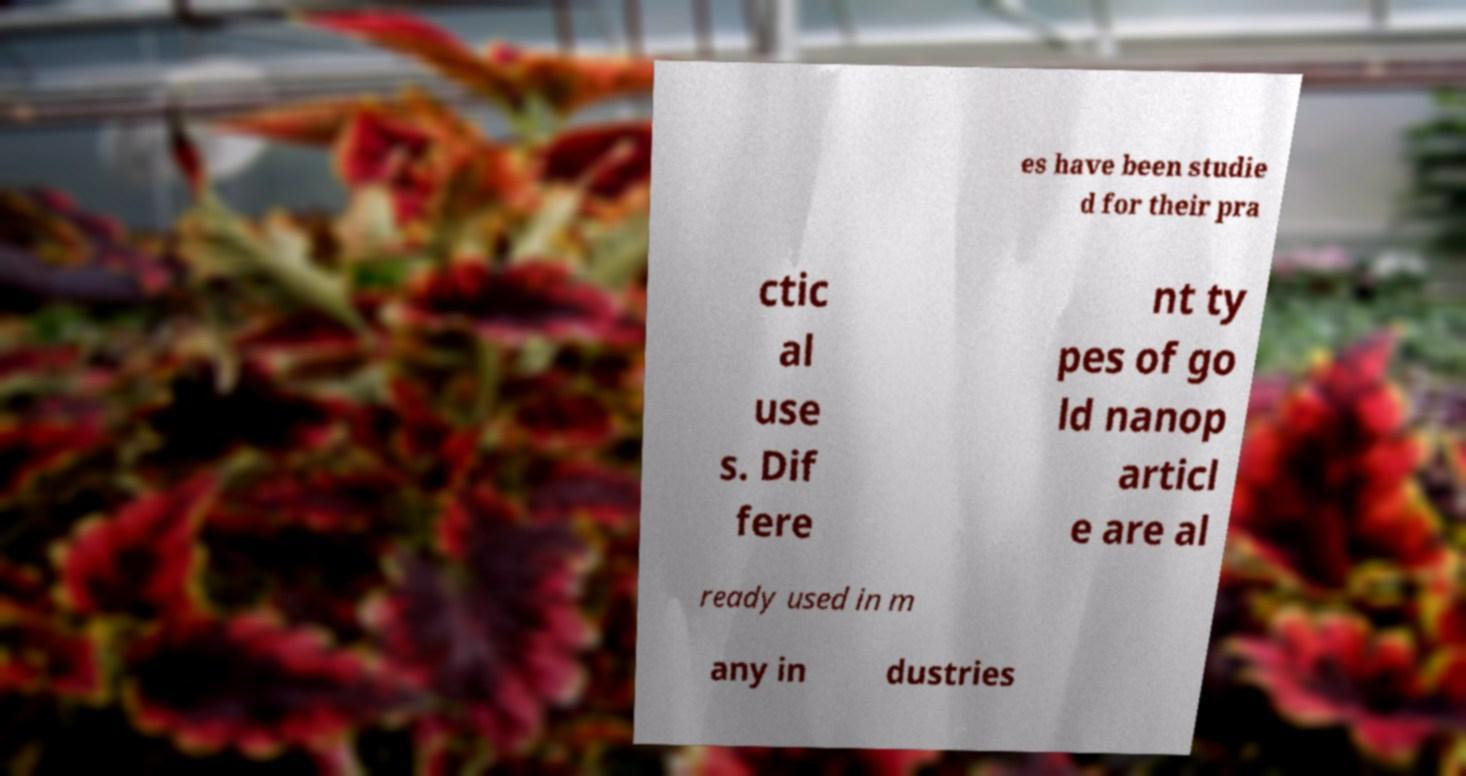For documentation purposes, I need the text within this image transcribed. Could you provide that? es have been studie d for their pra ctic al use s. Dif fere nt ty pes of go ld nanop articl e are al ready used in m any in dustries 